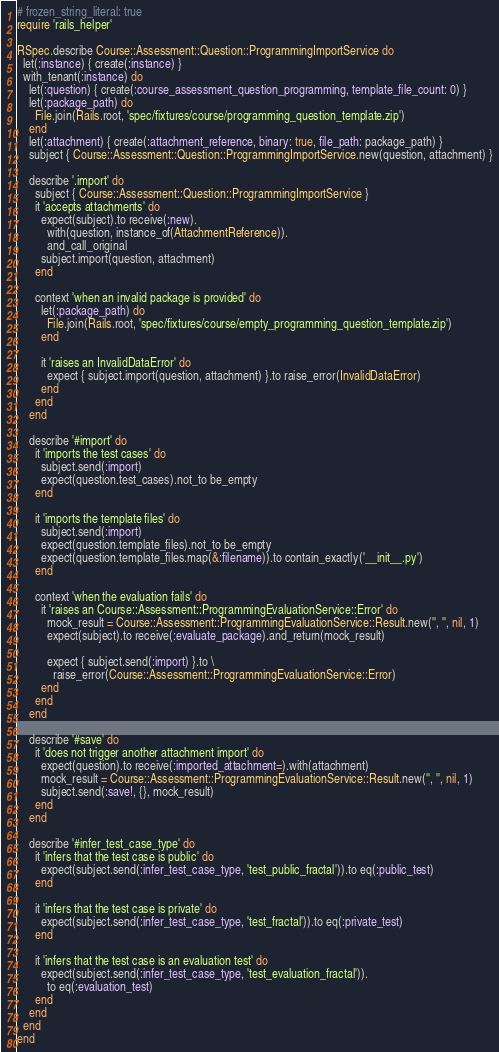<code> <loc_0><loc_0><loc_500><loc_500><_Ruby_># frozen_string_literal: true
require 'rails_helper'

RSpec.describe Course::Assessment::Question::ProgrammingImportService do
  let(:instance) { create(:instance) }
  with_tenant(:instance) do
    let(:question) { create(:course_assessment_question_programming, template_file_count: 0) }
    let(:package_path) do
      File.join(Rails.root, 'spec/fixtures/course/programming_question_template.zip')
    end
    let(:attachment) { create(:attachment_reference, binary: true, file_path: package_path) }
    subject { Course::Assessment::Question::ProgrammingImportService.new(question, attachment) }

    describe '.import' do
      subject { Course::Assessment::Question::ProgrammingImportService }
      it 'accepts attachments' do
        expect(subject).to receive(:new).
          with(question, instance_of(AttachmentReference)).
          and_call_original
        subject.import(question, attachment)
      end

      context 'when an invalid package is provided' do
        let(:package_path) do
          File.join(Rails.root, 'spec/fixtures/course/empty_programming_question_template.zip')
        end

        it 'raises an InvalidDataError' do
          expect { subject.import(question, attachment) }.to raise_error(InvalidDataError)
        end
      end
    end

    describe '#import' do
      it 'imports the test cases' do
        subject.send(:import)
        expect(question.test_cases).not_to be_empty
      end

      it 'imports the template files' do
        subject.send(:import)
        expect(question.template_files).not_to be_empty
        expect(question.template_files.map(&:filename)).to contain_exactly('__init__.py')
      end

      context 'when the evaluation fails' do
        it 'raises an Course::Assessment::ProgrammingEvaluationService::Error' do
          mock_result = Course::Assessment::ProgrammingEvaluationService::Result.new('', '', nil, 1)
          expect(subject).to receive(:evaluate_package).and_return(mock_result)

          expect { subject.send(:import) }.to \
            raise_error(Course::Assessment::ProgrammingEvaluationService::Error)
        end
      end
    end

    describe '#save' do
      it 'does not trigger another attachment import' do
        expect(question).to receive(:imported_attachment=).with(attachment)
        mock_result = Course::Assessment::ProgrammingEvaluationService::Result.new('', '', nil, 1)
        subject.send(:save!, {}, mock_result)
      end
    end

    describe '#infer_test_case_type' do
      it 'infers that the test case is public' do
        expect(subject.send(:infer_test_case_type, 'test_public_fractal')).to eq(:public_test)
      end

      it 'infers that the test case is private' do
        expect(subject.send(:infer_test_case_type, 'test_fractal')).to eq(:private_test)
      end

      it 'infers that the test case is an evaluation test' do
        expect(subject.send(:infer_test_case_type, 'test_evaluation_fractal')).
          to eq(:evaluation_test)
      end
    end
  end
end
</code> 